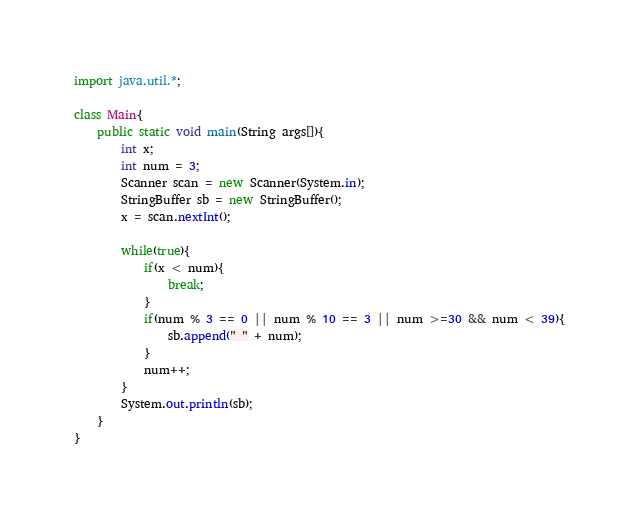<code> <loc_0><loc_0><loc_500><loc_500><_Java_>import java.util.*;

class Main{
	public static void main(String args[]){
		int x;
		int num = 3;
		Scanner scan = new Scanner(System.in);
		StringBuffer sb = new StringBuffer();
		x = scan.nextInt();

		while(true){
			if(x < num){
				break;
			}
			if(num % 3 == 0 || num % 10 == 3 || num >=30 && num < 39){
				sb.append(" " + num);
			}
			num++;
		}
		System.out.println(sb);
	}
}</code> 